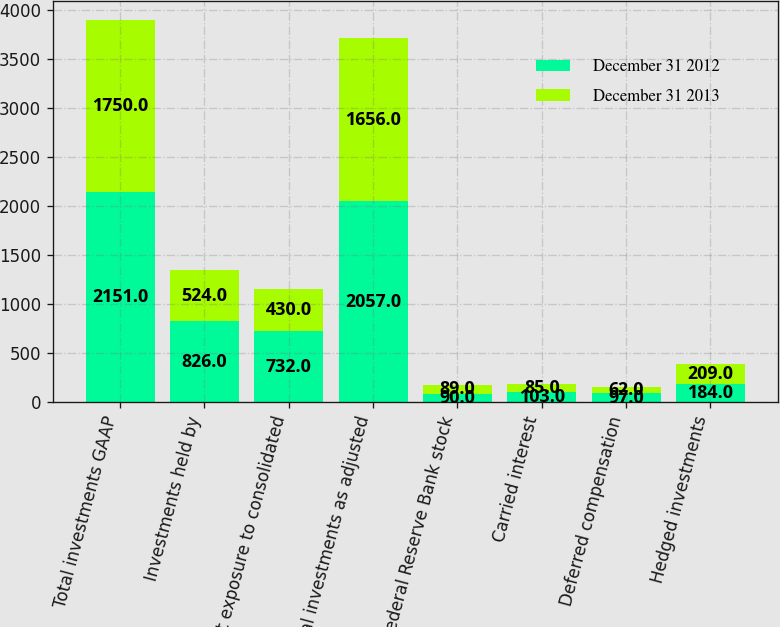Convert chart to OTSL. <chart><loc_0><loc_0><loc_500><loc_500><stacked_bar_chart><ecel><fcel>Total investments GAAP<fcel>Investments held by<fcel>Net exposure to consolidated<fcel>Total investments as adjusted<fcel>Federal Reserve Bank stock<fcel>Carried interest<fcel>Deferred compensation<fcel>Hedged investments<nl><fcel>December 31 2012<fcel>2151<fcel>826<fcel>732<fcel>2057<fcel>90<fcel>103<fcel>97<fcel>184<nl><fcel>December 31 2013<fcel>1750<fcel>524<fcel>430<fcel>1656<fcel>89<fcel>85<fcel>62<fcel>209<nl></chart> 